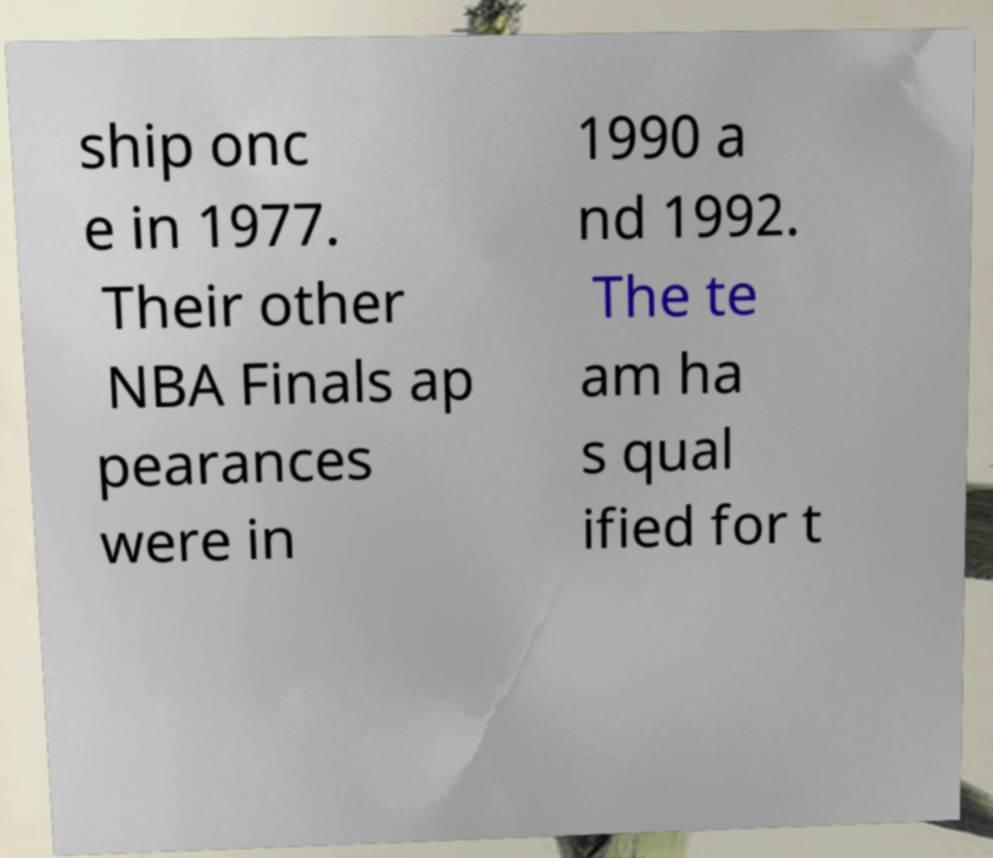For documentation purposes, I need the text within this image transcribed. Could you provide that? ship onc e in 1977. Their other NBA Finals ap pearances were in 1990 a nd 1992. The te am ha s qual ified for t 